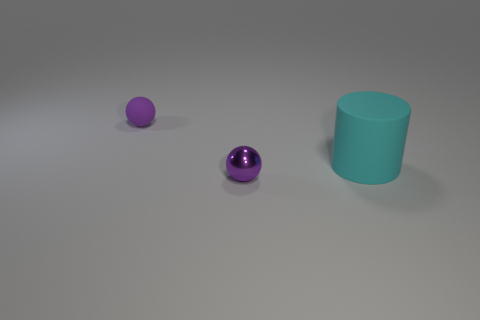There is a ball that is made of the same material as the cylinder; what size is it?
Make the answer very short. Small. How many purple things are small matte balls or small spheres?
Make the answer very short. 2. There is a thing in front of the cyan cylinder; what number of large cyan matte objects are in front of it?
Offer a terse response. 0. Are there more small rubber objects that are in front of the cylinder than objects right of the purple rubber ball?
Ensure brevity in your answer.  No. What is the material of the large cyan cylinder?
Provide a succinct answer. Rubber. Is there a red object that has the same size as the purple rubber ball?
Provide a succinct answer. No. What material is the other sphere that is the same size as the purple shiny ball?
Ensure brevity in your answer.  Rubber. How many big matte cylinders are there?
Provide a short and direct response. 1. What size is the thing that is behind the large cyan matte thing?
Make the answer very short. Small. Are there an equal number of tiny rubber balls that are in front of the big cyan cylinder and big red matte objects?
Give a very brief answer. Yes. 